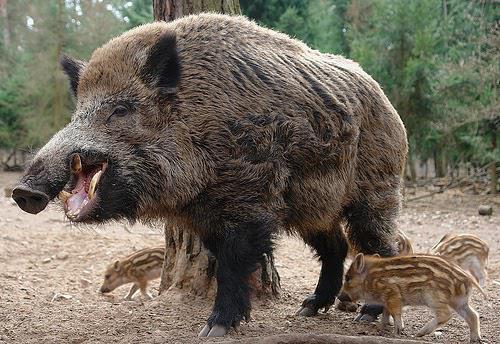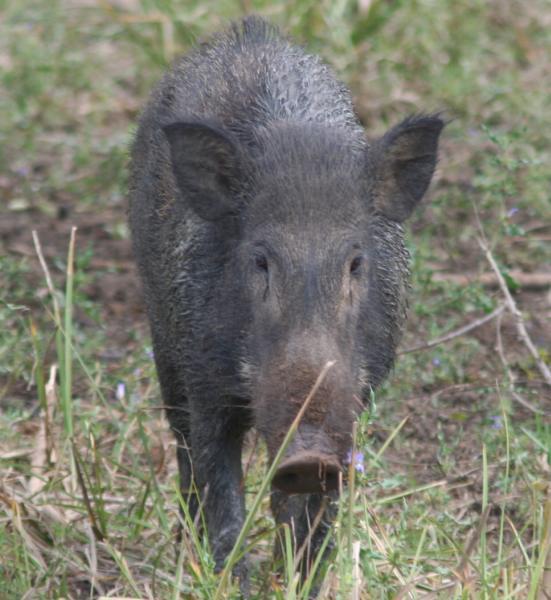The first image is the image on the left, the second image is the image on the right. Considering the images on both sides, is "One image shows a boar standing in the mud." valid? Answer yes or no. No. 